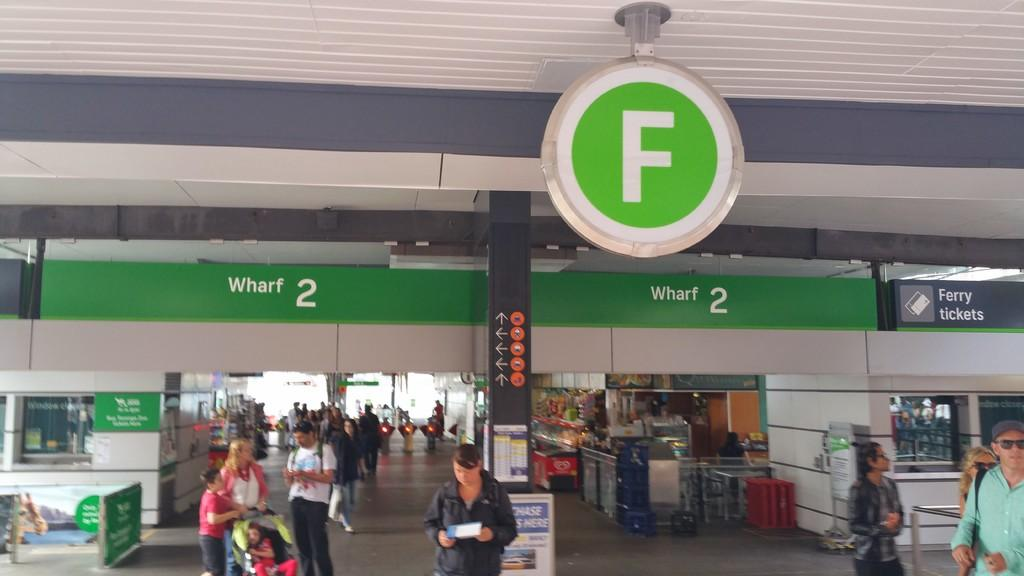<image>
Provide a brief description of the given image. People stand, some with strollers, some holding maps, in front of the F section of Wharf 2. 